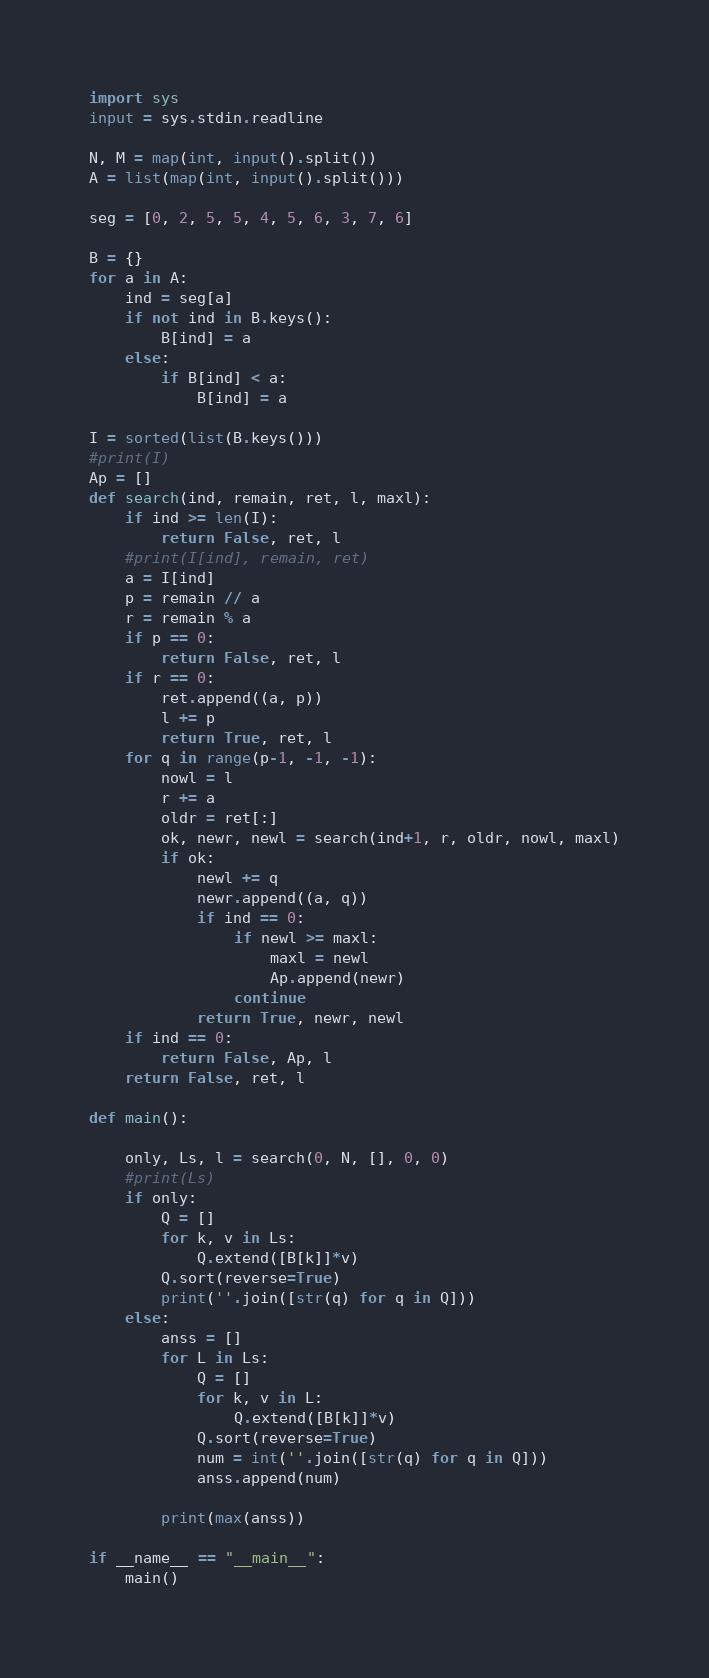<code> <loc_0><loc_0><loc_500><loc_500><_Python_>import sys
input = sys.stdin.readline

N, M = map(int, input().split()) 
A = list(map(int, input().split()))

seg = [0, 2, 5, 5, 4, 5, 6, 3, 7, 6]

B = {}
for a in A:
    ind = seg[a]
    if not ind in B.keys():
        B[ind] = a
    else:
        if B[ind] < a:
            B[ind] = a

I = sorted(list(B.keys()))
#print(I)
Ap = []
def search(ind, remain, ret, l, maxl):
    if ind >= len(I):
        return False, ret, l
    #print(I[ind], remain, ret)
    a = I[ind]
    p = remain // a
    r = remain % a 
    if p == 0:
        return False, ret, l
    if r == 0:
        ret.append((a, p))
        l += p
        return True, ret, l
    for q in range(p-1, -1, -1):
        nowl = l
        r += a
        oldr = ret[:]
        ok, newr, newl = search(ind+1, r, oldr, nowl, maxl)
        if ok:
            newl += q
            newr.append((a, q))
            if ind == 0:
                if newl >= maxl:
                    maxl = newl
                    Ap.append(newr)
                continue
            return True, newr, newl
    if ind == 0:
        return False, Ap, l
    return False, ret, l

def main():

    only, Ls, l = search(0, N, [], 0, 0)
    #print(Ls)
    if only:
        Q = []
        for k, v in Ls:
            Q.extend([B[k]]*v)
        Q.sort(reverse=True)
        print(''.join([str(q) for q in Q]))
    else:
        anss = []
        for L in Ls:
            Q = []
            for k, v in L:
                Q.extend([B[k]]*v)
            Q.sort(reverse=True)
            num = int(''.join([str(q) for q in Q]))
            anss.append(num)

        print(max(anss))

if __name__ == "__main__":
    main()</code> 